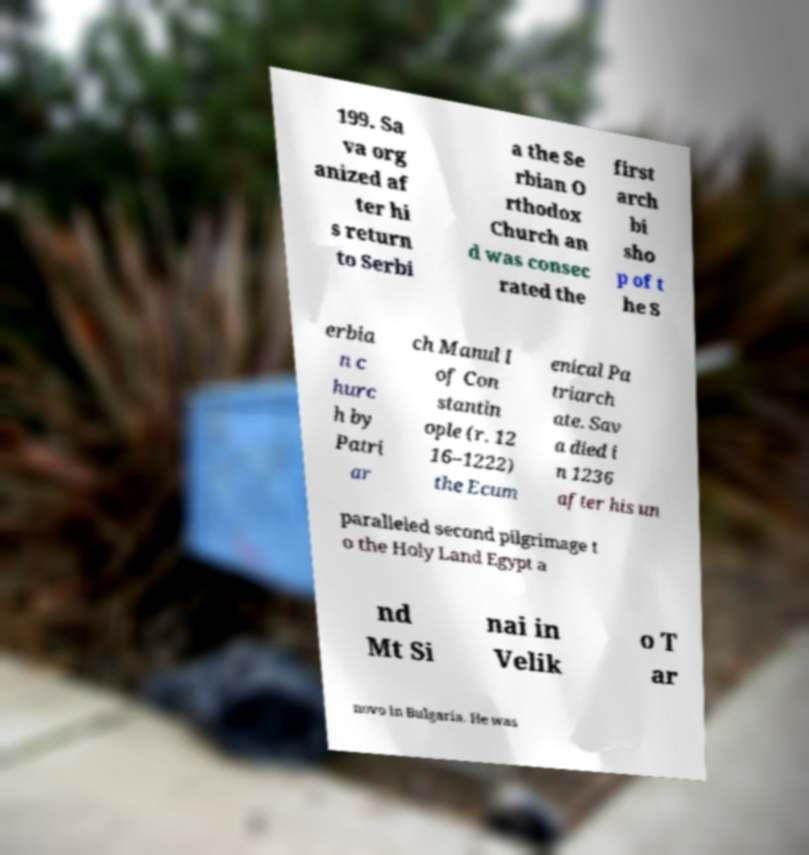Could you assist in decoding the text presented in this image and type it out clearly? 199. Sa va org anized af ter hi s return to Serbi a the Se rbian O rthodox Church an d was consec rated the first arch bi sho p of t he S erbia n c hurc h by Patri ar ch Manul I of Con stantin ople (r. 12 16–1222) the Ecum enical Pa triarch ate. Sav a died i n 1236 after his un paralleled second pilgrimage t o the Holy Land Egypt a nd Mt Si nai in Velik o T ar novo in Bulgaria. He was 